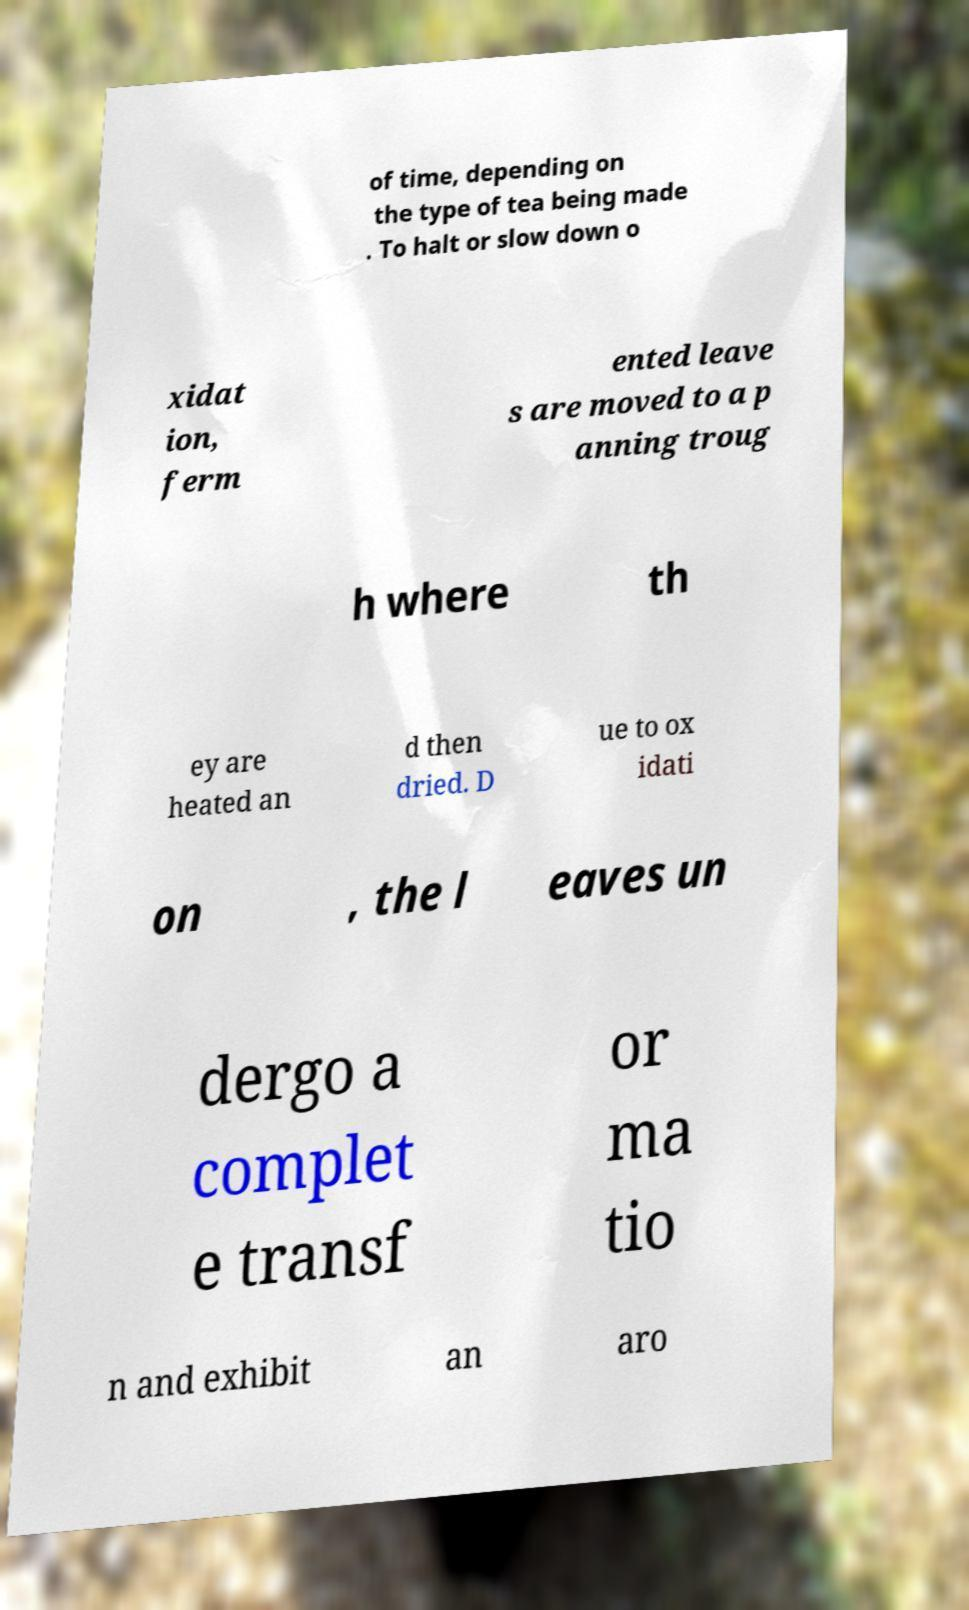Please read and relay the text visible in this image. What does it say? of time, depending on the type of tea being made . To halt or slow down o xidat ion, ferm ented leave s are moved to a p anning troug h where th ey are heated an d then dried. D ue to ox idati on , the l eaves un dergo a complet e transf or ma tio n and exhibit an aro 